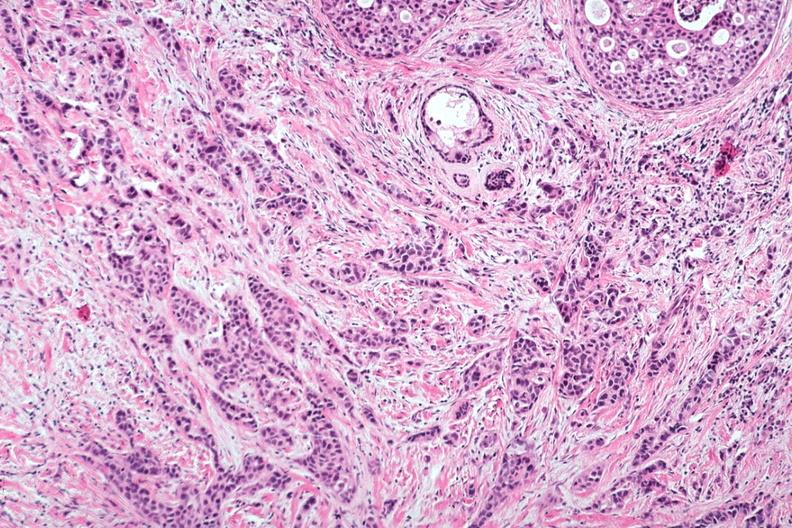s papillary intraductal adenocarcinoma present?
Answer the question using a single word or phrase. Yes 